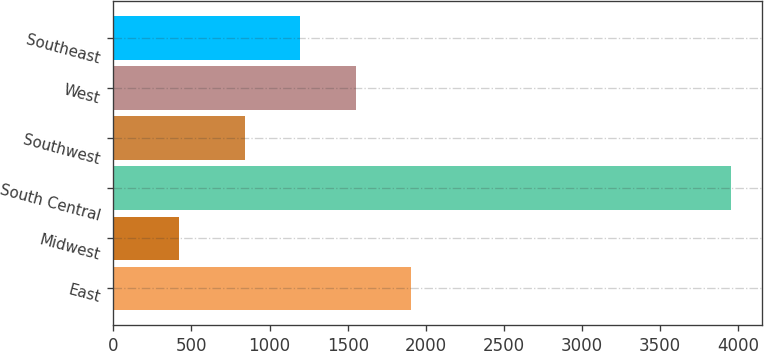<chart> <loc_0><loc_0><loc_500><loc_500><bar_chart><fcel>East<fcel>Midwest<fcel>South Central<fcel>Southwest<fcel>West<fcel>Southeast<nl><fcel>1904.1<fcel>419<fcel>3956<fcel>843<fcel>1550.4<fcel>1196.7<nl></chart> 